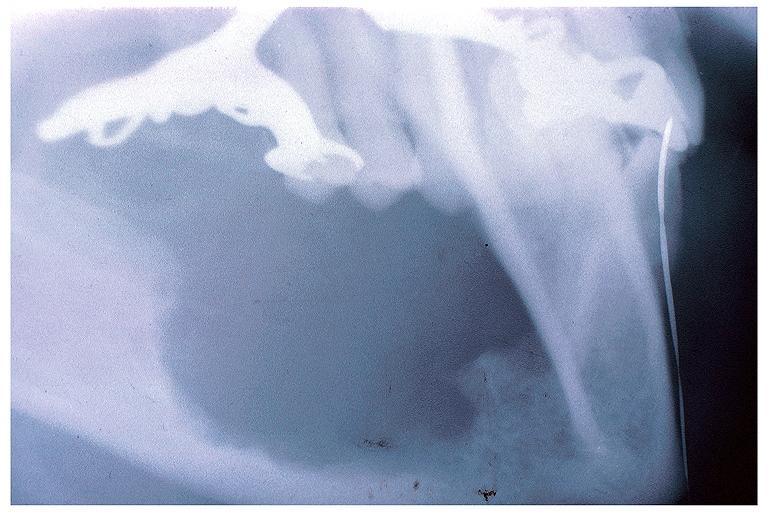does multiple myeloma show intraosseous mucoepidermoid carcinoma?
Answer the question using a single word or phrase. No 